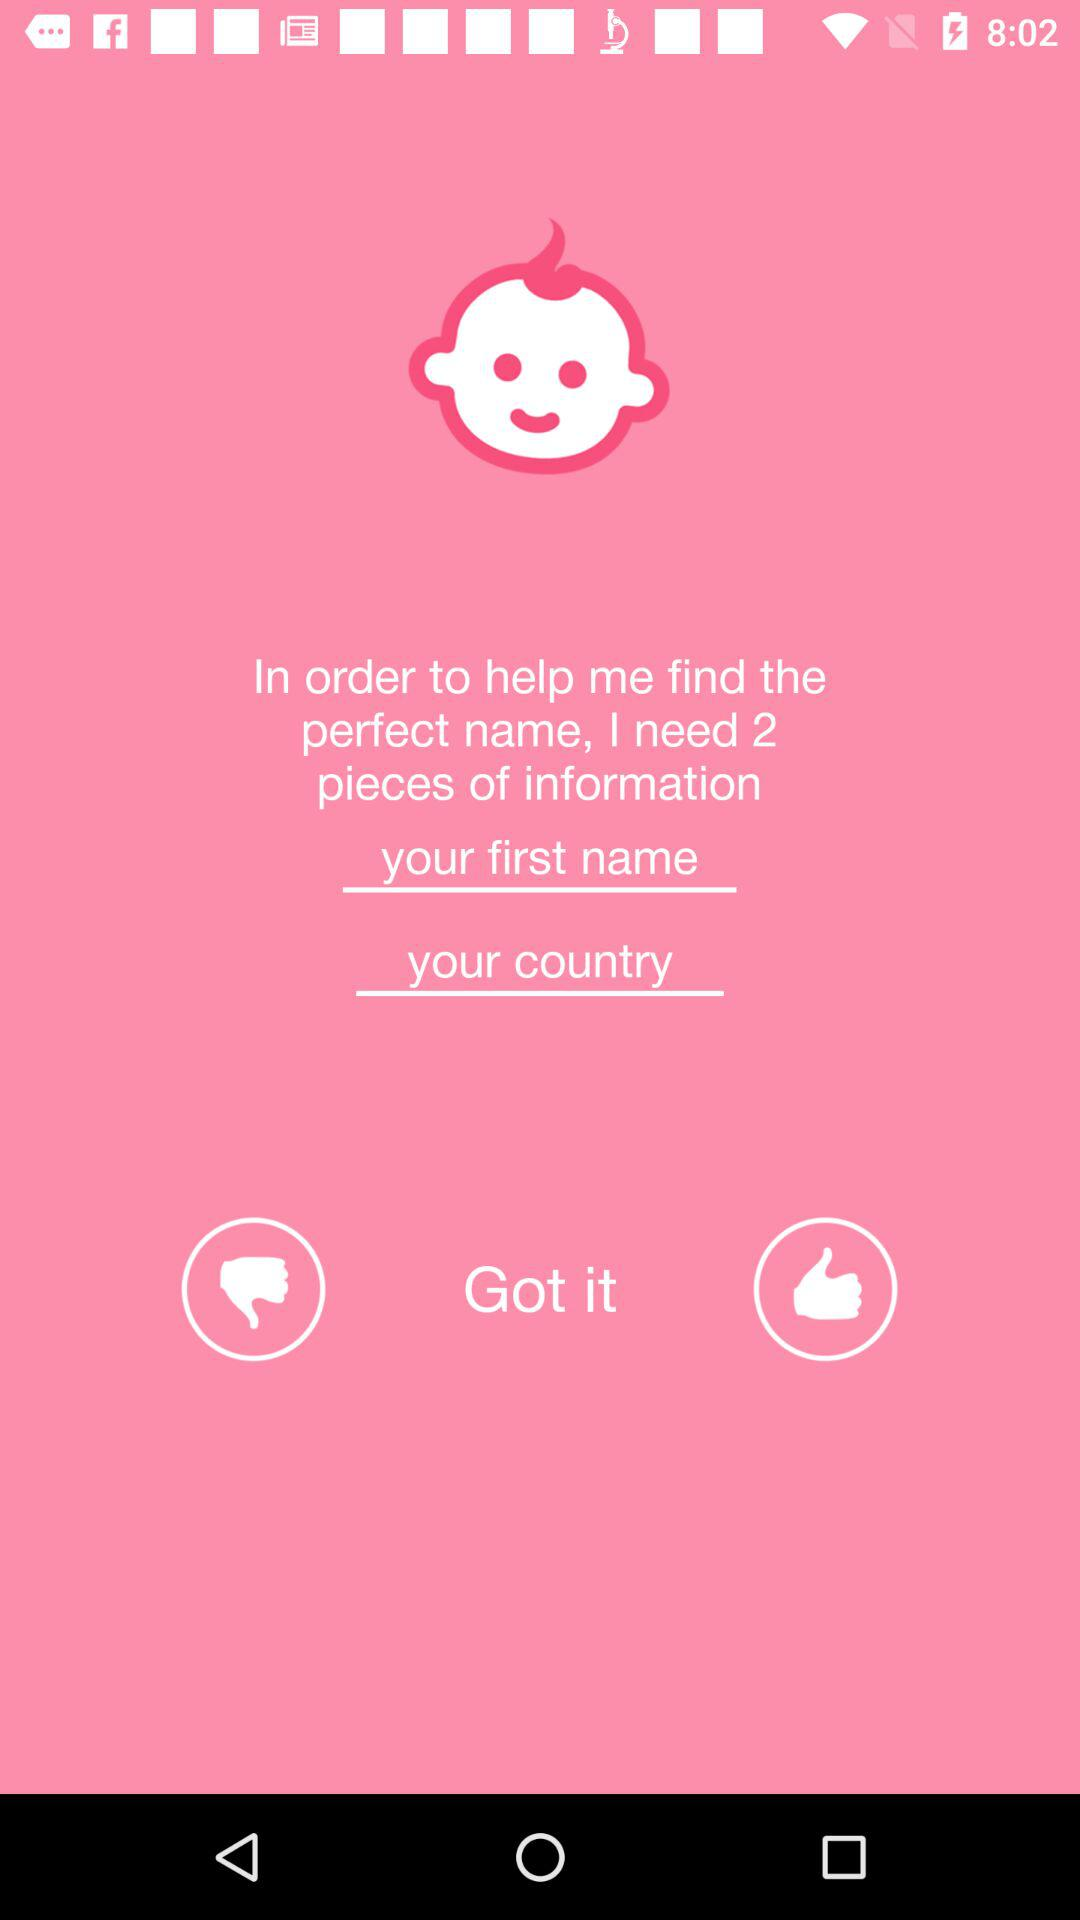How much information is needed? You need 2 pieces of information. 